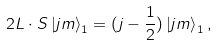Convert formula to latex. <formula><loc_0><loc_0><loc_500><loc_500>2 { L \cdot S } \left | j m \right > _ { 1 } = ( j - \frac { 1 } { 2 } ) \left | j m \right > _ { 1 } ,</formula> 